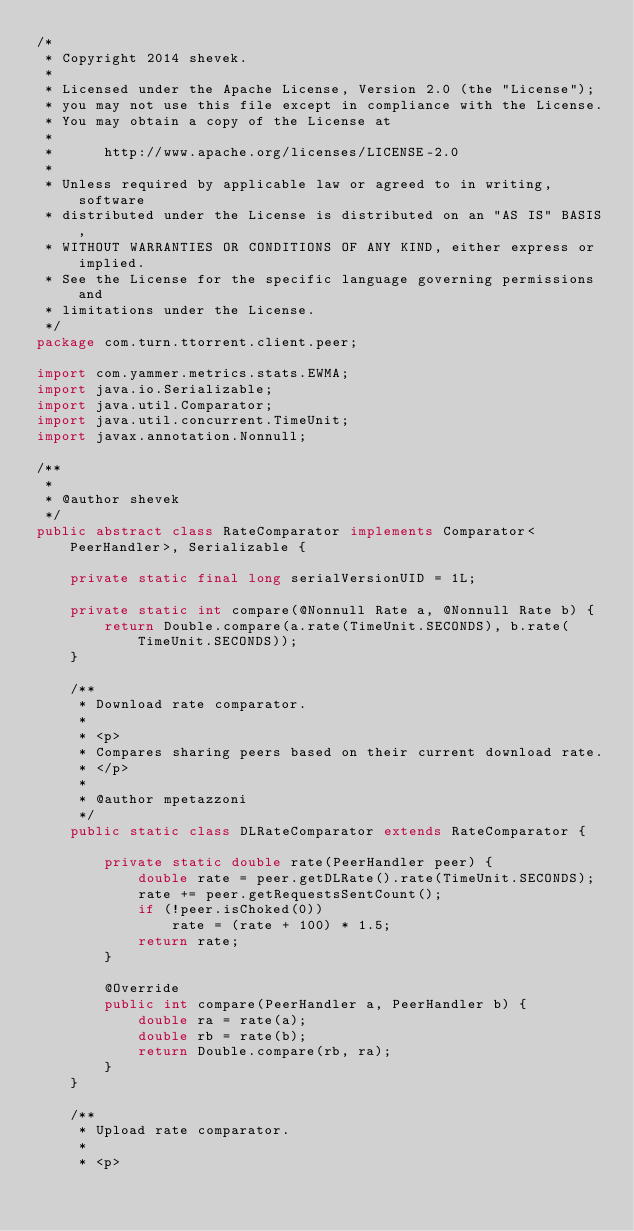<code> <loc_0><loc_0><loc_500><loc_500><_Java_>/*
 * Copyright 2014 shevek.
 *
 * Licensed under the Apache License, Version 2.0 (the "License");
 * you may not use this file except in compliance with the License.
 * You may obtain a copy of the License at
 *
 *      http://www.apache.org/licenses/LICENSE-2.0
 *
 * Unless required by applicable law or agreed to in writing, software
 * distributed under the License is distributed on an "AS IS" BASIS,
 * WITHOUT WARRANTIES OR CONDITIONS OF ANY KIND, either express or implied.
 * See the License for the specific language governing permissions and
 * limitations under the License.
 */
package com.turn.ttorrent.client.peer;

import com.yammer.metrics.stats.EWMA;
import java.io.Serializable;
import java.util.Comparator;
import java.util.concurrent.TimeUnit;
import javax.annotation.Nonnull;

/**
 *
 * @author shevek
 */
public abstract class RateComparator implements Comparator<PeerHandler>, Serializable {

    private static final long serialVersionUID = 1L;

    private static int compare(@Nonnull Rate a, @Nonnull Rate b) {
        return Double.compare(a.rate(TimeUnit.SECONDS), b.rate(TimeUnit.SECONDS));
    }

    /**
     * Download rate comparator.
     *
     * <p>
     * Compares sharing peers based on their current download rate.
     * </p>
     *
     * @author mpetazzoni
     */
    public static class DLRateComparator extends RateComparator {

        private static double rate(PeerHandler peer) {
            double rate = peer.getDLRate().rate(TimeUnit.SECONDS);
            rate += peer.getRequestsSentCount();
            if (!peer.isChoked(0))
                rate = (rate + 100) * 1.5;
            return rate;
        }

        @Override
        public int compare(PeerHandler a, PeerHandler b) {
            double ra = rate(a);
            double rb = rate(b);
            return Double.compare(rb, ra);
        }
    }

    /**
     * Upload rate comparator.
     *
     * <p></code> 